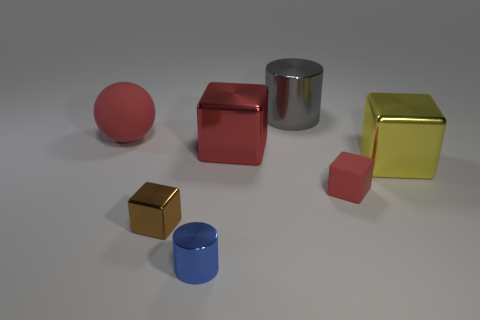There is a red matte thing left of the large metal thing that is behind the red matte ball; what is its shape?
Your answer should be very brief. Sphere. What number of big yellow metallic objects are on the left side of the big red sphere?
Offer a very short reply. 0. There is a large ball that is made of the same material as the small red cube; what color is it?
Offer a terse response. Red. Does the blue metal thing have the same size as the metal block in front of the yellow metal cube?
Your answer should be very brief. Yes. There is a metallic cylinder that is behind the red thing that is on the left side of the cylinder in front of the red sphere; how big is it?
Make the answer very short. Large. How many metallic things are either tiny red spheres or small brown blocks?
Give a very brief answer. 1. There is a cylinder in front of the gray cylinder; what color is it?
Offer a terse response. Blue. What is the shape of the blue object that is the same size as the brown cube?
Ensure brevity in your answer.  Cylinder. There is a tiny metallic block; is its color the same as the matte thing that is to the left of the small metal block?
Offer a very short reply. No. How many things are shiny blocks that are in front of the yellow metallic block or red matte things in front of the large rubber sphere?
Keep it short and to the point. 2. 